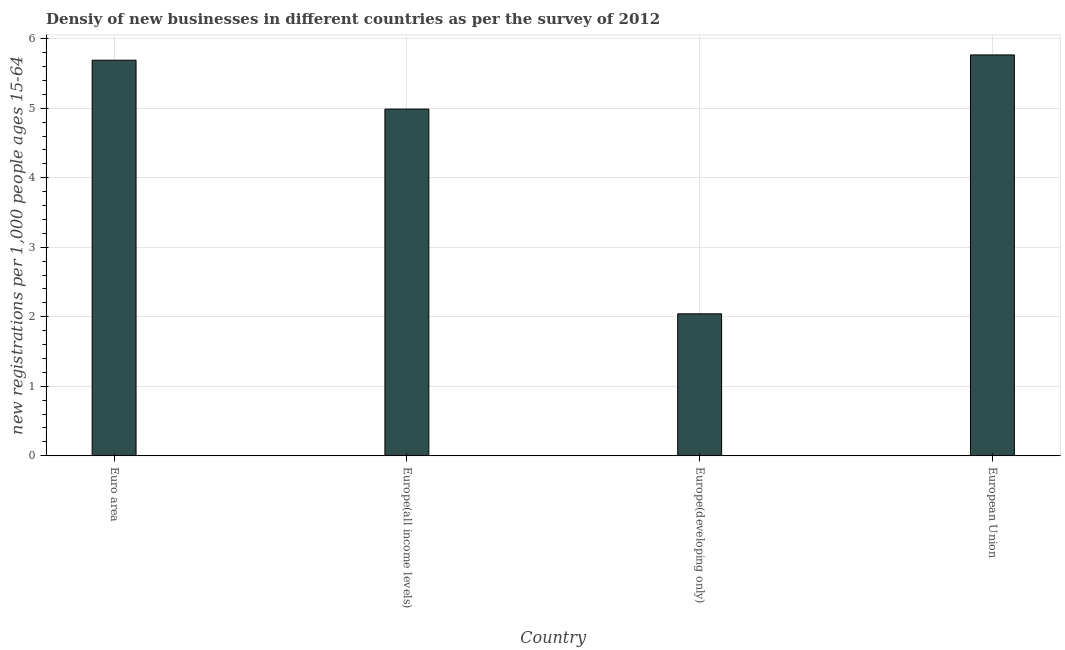What is the title of the graph?
Your answer should be very brief. Densiy of new businesses in different countries as per the survey of 2012. What is the label or title of the Y-axis?
Your answer should be very brief. New registrations per 1,0 people ages 15-64. What is the density of new business in Euro area?
Give a very brief answer. 5.69. Across all countries, what is the maximum density of new business?
Your answer should be very brief. 5.77. Across all countries, what is the minimum density of new business?
Provide a short and direct response. 2.04. In which country was the density of new business maximum?
Make the answer very short. European Union. In which country was the density of new business minimum?
Offer a very short reply. Europe(developing only). What is the sum of the density of new business?
Your response must be concise. 18.49. What is the difference between the density of new business in Euro area and Europe(developing only)?
Provide a succinct answer. 3.65. What is the average density of new business per country?
Your answer should be very brief. 4.62. What is the median density of new business?
Offer a very short reply. 5.34. In how many countries, is the density of new business greater than 5.4 ?
Ensure brevity in your answer.  2. What is the ratio of the density of new business in Euro area to that in Europe(all income levels)?
Provide a succinct answer. 1.14. What is the difference between the highest and the second highest density of new business?
Provide a succinct answer. 0.08. What is the difference between the highest and the lowest density of new business?
Your answer should be very brief. 3.73. How many countries are there in the graph?
Your answer should be very brief. 4. What is the new registrations per 1,000 people ages 15-64 of Euro area?
Your answer should be very brief. 5.69. What is the new registrations per 1,000 people ages 15-64 of Europe(all income levels)?
Ensure brevity in your answer.  4.99. What is the new registrations per 1,000 people ages 15-64 of Europe(developing only)?
Offer a terse response. 2.04. What is the new registrations per 1,000 people ages 15-64 in European Union?
Keep it short and to the point. 5.77. What is the difference between the new registrations per 1,000 people ages 15-64 in Euro area and Europe(all income levels)?
Provide a succinct answer. 0.7. What is the difference between the new registrations per 1,000 people ages 15-64 in Euro area and Europe(developing only)?
Make the answer very short. 3.65. What is the difference between the new registrations per 1,000 people ages 15-64 in Euro area and European Union?
Give a very brief answer. -0.08. What is the difference between the new registrations per 1,000 people ages 15-64 in Europe(all income levels) and Europe(developing only)?
Keep it short and to the point. 2.95. What is the difference between the new registrations per 1,000 people ages 15-64 in Europe(all income levels) and European Union?
Your response must be concise. -0.78. What is the difference between the new registrations per 1,000 people ages 15-64 in Europe(developing only) and European Union?
Offer a terse response. -3.73. What is the ratio of the new registrations per 1,000 people ages 15-64 in Euro area to that in Europe(all income levels)?
Provide a succinct answer. 1.14. What is the ratio of the new registrations per 1,000 people ages 15-64 in Euro area to that in Europe(developing only)?
Ensure brevity in your answer.  2.79. What is the ratio of the new registrations per 1,000 people ages 15-64 in Europe(all income levels) to that in Europe(developing only)?
Provide a short and direct response. 2.44. What is the ratio of the new registrations per 1,000 people ages 15-64 in Europe(all income levels) to that in European Union?
Offer a terse response. 0.86. What is the ratio of the new registrations per 1,000 people ages 15-64 in Europe(developing only) to that in European Union?
Offer a terse response. 0.35. 